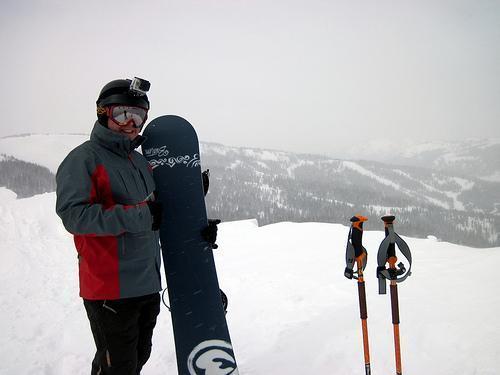How many men are there?
Give a very brief answer. 1. 